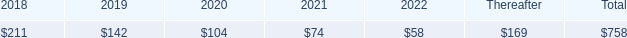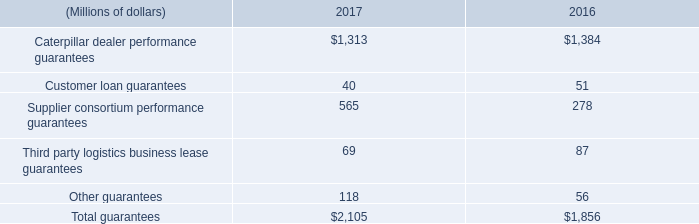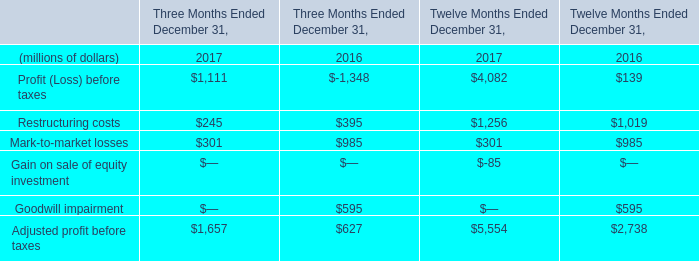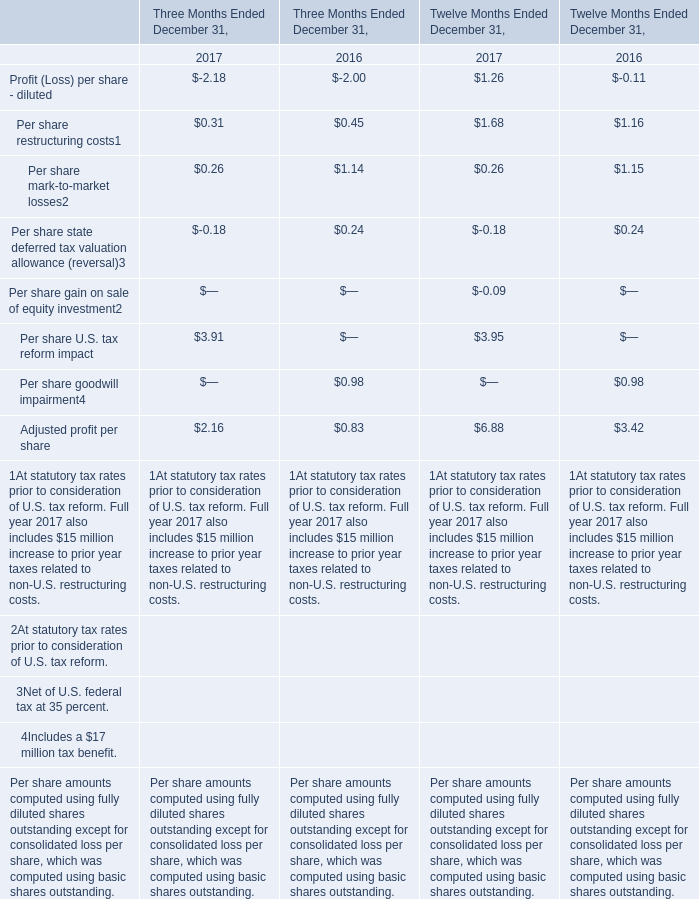What is the average amount of Restructuring costs of Twelve Months Ended December 31, 2017, and Caterpillar dealer performance guarantees of 2016 ? 
Computations: ((1256.0 + 1384.0) / 2)
Answer: 1320.0. 